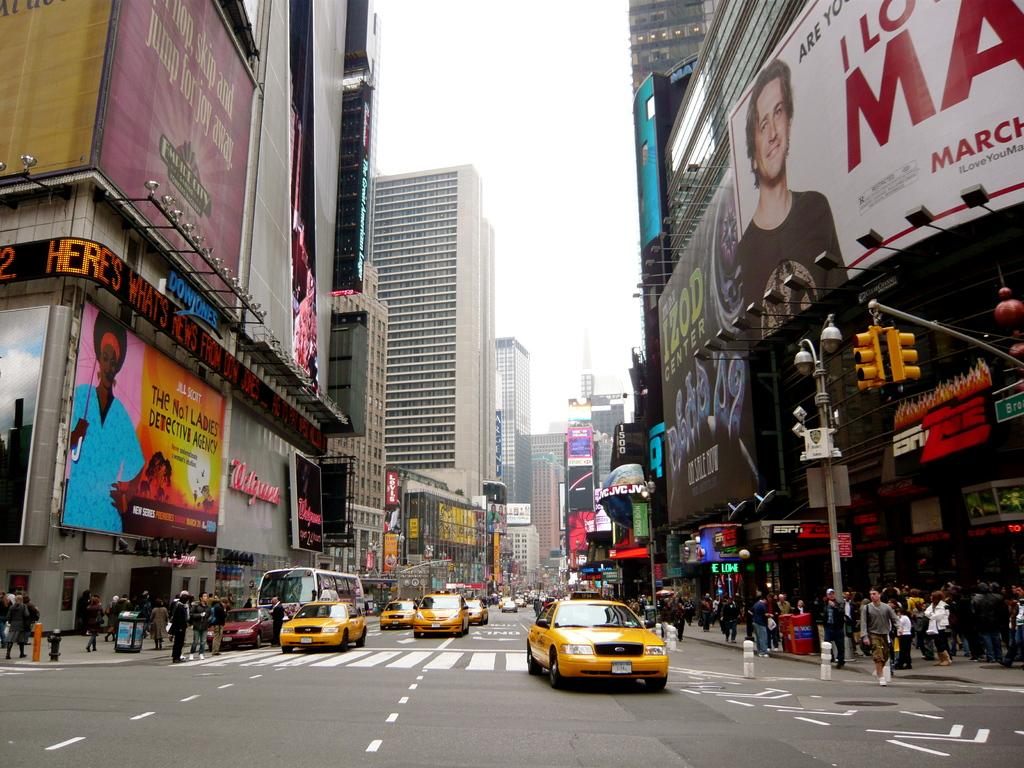Provide a one-sentence caption for the provided image. Several taxis are driving down a busy city street past a building that says Walgreen's. 